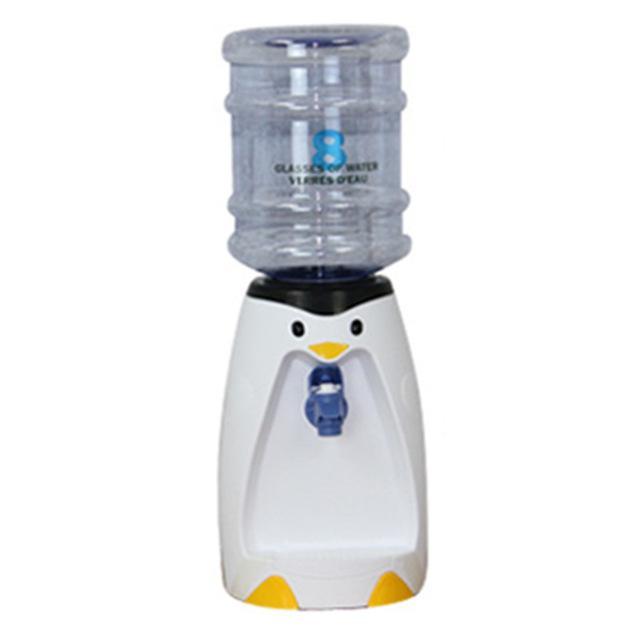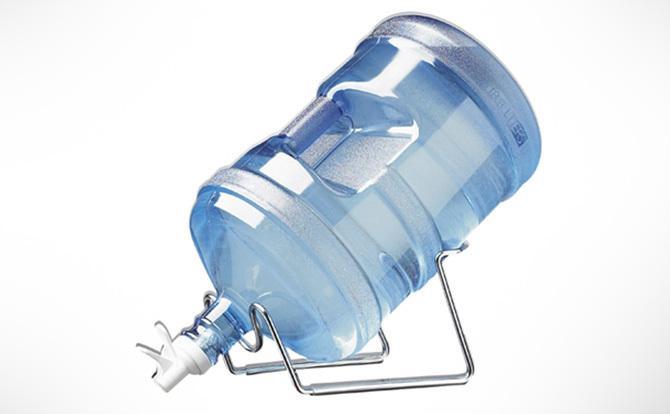The first image is the image on the left, the second image is the image on the right. Analyze the images presented: Is the assertion "The right image shows an inverted blue water jug, and the left image includes a water jug and a dispenser that looks like a penguin." valid? Answer yes or no. Yes. The first image is the image on the left, the second image is the image on the right. Analyze the images presented: Is the assertion "In at least one image there is a single water bottle twisted into a penguin water dispenser." valid? Answer yes or no. Yes. 